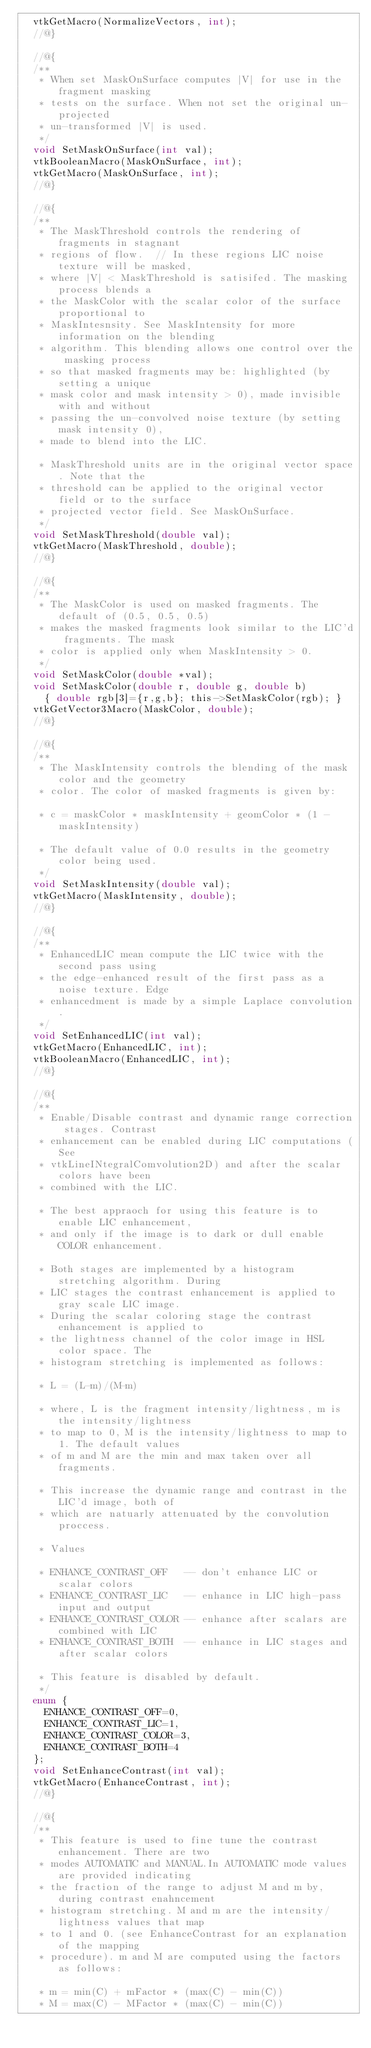<code> <loc_0><loc_0><loc_500><loc_500><_C_>  vtkGetMacro(NormalizeVectors, int);
  //@}

  //@{
  /**
   * When set MaskOnSurface computes |V| for use in the fragment masking
   * tests on the surface. When not set the original un-projected
   * un-transformed |V| is used.
   */
  void SetMaskOnSurface(int val);
  vtkBooleanMacro(MaskOnSurface, int);
  vtkGetMacro(MaskOnSurface, int);
  //@}

  //@{
  /**
   * The MaskThreshold controls the rendering of fragments in stagnant
   * regions of flow.  // In these regions LIC noise texture will be masked,
   * where |V| < MaskThreshold is satisifed. The masking process blends a
   * the MaskColor with the scalar color of the surface proportional to
   * MaskIntesnsity. See MaskIntensity for more information on the blending
   * algorithm. This blending allows one control over the masking process
   * so that masked fragments may be: highlighted (by setting a unique
   * mask color and mask intensity > 0), made invisible with and without
   * passing the un-convolved noise texture (by setting mask intensity 0),
   * made to blend into the LIC.

   * MaskThreshold units are in the original vector space. Note that the
   * threshold can be applied to the original vector field or to the surface
   * projected vector field. See MaskOnSurface.
   */
  void SetMaskThreshold(double val);
  vtkGetMacro(MaskThreshold, double);
  //@}

  //@{
  /**
   * The MaskColor is used on masked fragments. The default of (0.5, 0.5, 0.5)
   * makes the masked fragments look similar to the LIC'd fragments. The mask
   * color is applied only when MaskIntensity > 0.
   */
  void SetMaskColor(double *val);
  void SetMaskColor(double r, double g, double b)
    { double rgb[3]={r,g,b}; this->SetMaskColor(rgb); }
  vtkGetVector3Macro(MaskColor, double);
  //@}

  //@{
  /**
   * The MaskIntensity controls the blending of the mask color and the geometry
   * color. The color of masked fragments is given by:

   * c = maskColor * maskIntensity + geomColor * (1 - maskIntensity)

   * The default value of 0.0 results in the geometry color being used.
   */
  void SetMaskIntensity(double val);
  vtkGetMacro(MaskIntensity, double);
  //@}

  //@{
  /**
   * EnhancedLIC mean compute the LIC twice with the second pass using
   * the edge-enhanced result of the first pass as a noise texture. Edge
   * enhancedment is made by a simple Laplace convolution.
   */
  void SetEnhancedLIC(int val);
  vtkGetMacro(EnhancedLIC, int);
  vtkBooleanMacro(EnhancedLIC, int);
  //@}

  //@{
  /**
   * Enable/Disable contrast and dynamic range correction stages. Contrast
   * enhancement can be enabled during LIC computations (See
   * vtkLineINtegralComvolution2D) and after the scalar colors have been
   * combined with the LIC.

   * The best appraoch for using this feature is to enable LIC enhancement,
   * and only if the image is to dark or dull enable COLOR enhancement.

   * Both stages are implemented by a histogram stretching algorithm. During
   * LIC stages the contrast enhancement is applied to gray scale LIC image.
   * During the scalar coloring stage the contrast enhancement is applied to
   * the lightness channel of the color image in HSL color space. The
   * histogram stretching is implemented as follows:

   * L = (L-m)/(M-m)

   * where, L is the fragment intensity/lightness, m is the intensity/lightness
   * to map to 0, M is the intensity/lightness to map to 1. The default values
   * of m and M are the min and max taken over all fragments.

   * This increase the dynamic range and contrast in the LIC'd image, both of
   * which are natuarly attenuated by the convolution proccess.

   * Values

   * ENHANCE_CONTRAST_OFF   -- don't enhance LIC or scalar colors
   * ENHANCE_CONTRAST_LIC   -- enhance in LIC high-pass input and output
   * ENHANCE_CONTRAST_COLOR -- enhance after scalars are combined with LIC
   * ENHANCE_CONTRAST_BOTH  -- enhance in LIC stages and after scalar colors

   * This feature is disabled by default.
   */
  enum {
    ENHANCE_CONTRAST_OFF=0,
    ENHANCE_CONTRAST_LIC=1,
    ENHANCE_CONTRAST_COLOR=3,
    ENHANCE_CONTRAST_BOTH=4
  };
  void SetEnhanceContrast(int val);
  vtkGetMacro(EnhanceContrast, int);
  //@}

  //@{
  /**
   * This feature is used to fine tune the contrast enhancement. There are two
   * modes AUTOMATIC and MANUAL.In AUTOMATIC mode values are provided indicating
   * the fraction of the range to adjust M and m by, during contrast enahncement
   * histogram stretching. M and m are the intensity/lightness values that map
   * to 1 and 0. (see EnhanceContrast for an explanation of the mapping
   * procedure). m and M are computed using the factors as follows:

   * m = min(C) + mFactor * (max(C) - min(C))
   * M = max(C) - MFactor * (max(C) - min(C))
</code> 